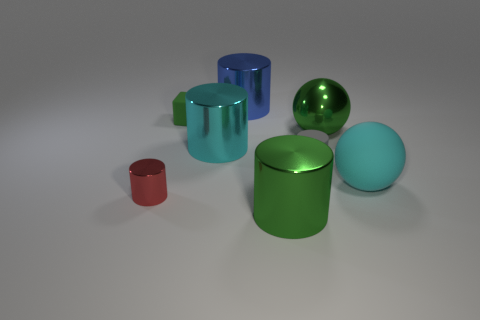Is the number of metallic things to the right of the tiny metal cylinder the same as the number of green metal cylinders to the left of the small gray matte cylinder?
Your answer should be very brief. No. What number of other things are there of the same shape as the gray rubber thing?
Your response must be concise. 4. Do the cyan object that is on the right side of the big blue cylinder and the cylinder left of the matte cube have the same size?
Provide a short and direct response. No. How many cubes are big cyan rubber things or gray matte things?
Provide a succinct answer. 0. How many metallic objects are either gray things or red things?
Give a very brief answer. 1. What is the size of the gray matte object that is the same shape as the big cyan metal object?
Your response must be concise. Small. There is a green metallic cylinder; is its size the same as the rubber object left of the large green metallic cylinder?
Make the answer very short. No. There is a large green thing that is in front of the tiny red metallic object; what shape is it?
Offer a very short reply. Cylinder. What color is the big metallic cylinder to the right of the metallic thing that is behind the small rubber block?
Give a very brief answer. Green. The small rubber object that is the same shape as the cyan shiny object is what color?
Your answer should be compact. Gray. 